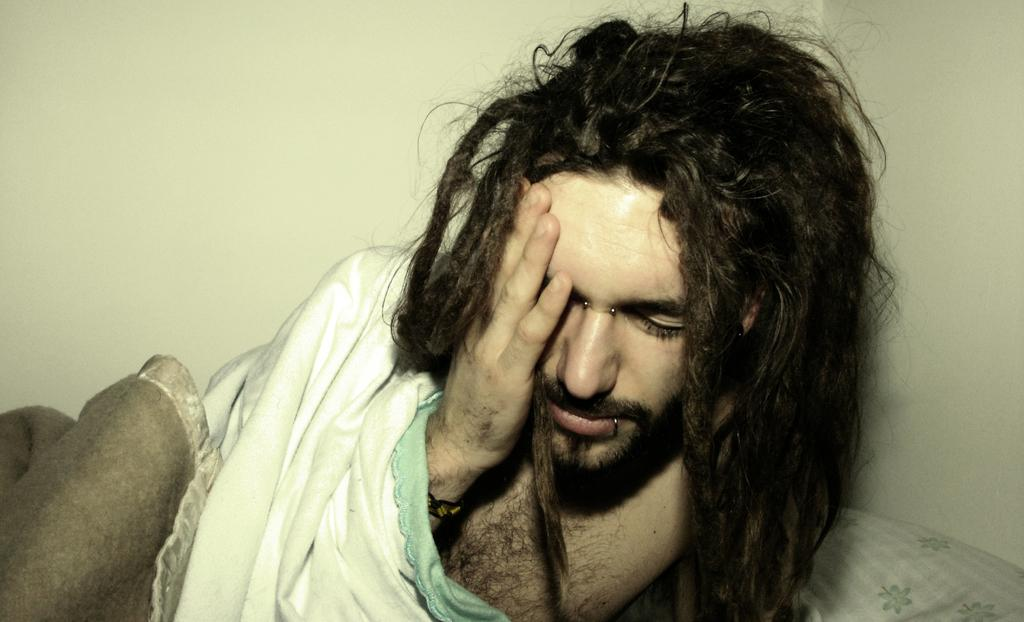Where was the image taken? The image is taken indoors. What can be seen in the background of the image? There is a wall in the background of the image. What is the man in the image doing? The man is lying on the bed in the image. What is covering the bed in the image? There is a blanket on the bed in the image. What type of hammer is the man using to fix the system in the image? There is no hammer or system present in the image; it features a man lying on a bed with a blanket. 